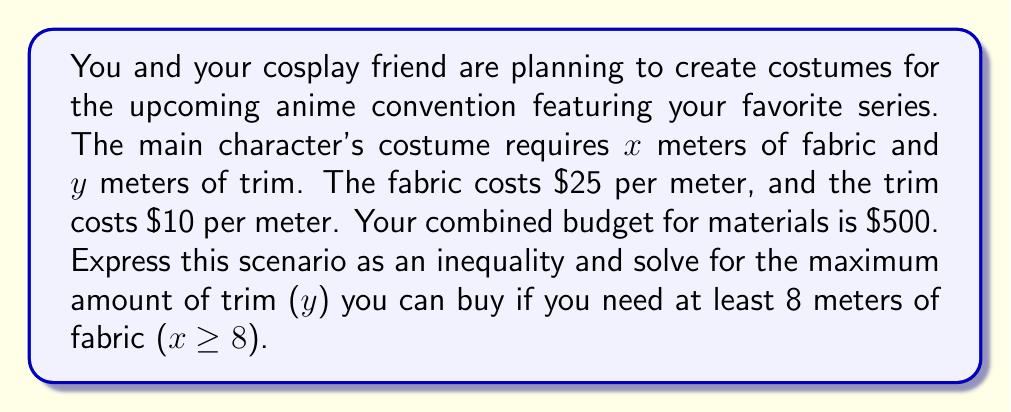What is the answer to this math problem? Let's approach this step-by-step:

1) First, let's express the total cost of materials as an inequality:
   $$25x + 10y \leq 500$$

2) We're told that $x \geq 8$, so we need to consider this constraint as well.

3) To find the maximum amount of trim ($y$) we can buy, we should use the minimum amount of fabric required, which is 8 meters. So, let's substitute $x = 8$ into our inequality:
   $$25(8) + 10y \leq 500$$

4) Simplify:
   $$200 + 10y \leq 500$$

5) Subtract 200 from both sides:
   $$10y \leq 300$$

6) Divide both sides by 10:
   $$y \leq 30$$

Therefore, the maximum amount of trim you can buy is 30 meters.
Answer: $y \leq 30$ meters 